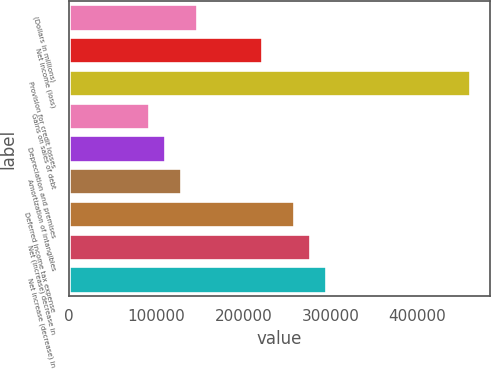Convert chart to OTSL. <chart><loc_0><loc_0><loc_500><loc_500><bar_chart><fcel>(Dollars in millions)<fcel>Net income (loss)<fcel>Provision for credit losses<fcel>Gains on sales of debt<fcel>Depreciation and premises<fcel>Amortization of intangibles<fcel>Deferred income tax expense<fcel>Net (increase) decrease in<fcel>Net increase (decrease) in<nl><fcel>147397<fcel>221067<fcel>460496<fcel>92144<fcel>110562<fcel>128979<fcel>257902<fcel>276320<fcel>294738<nl></chart> 